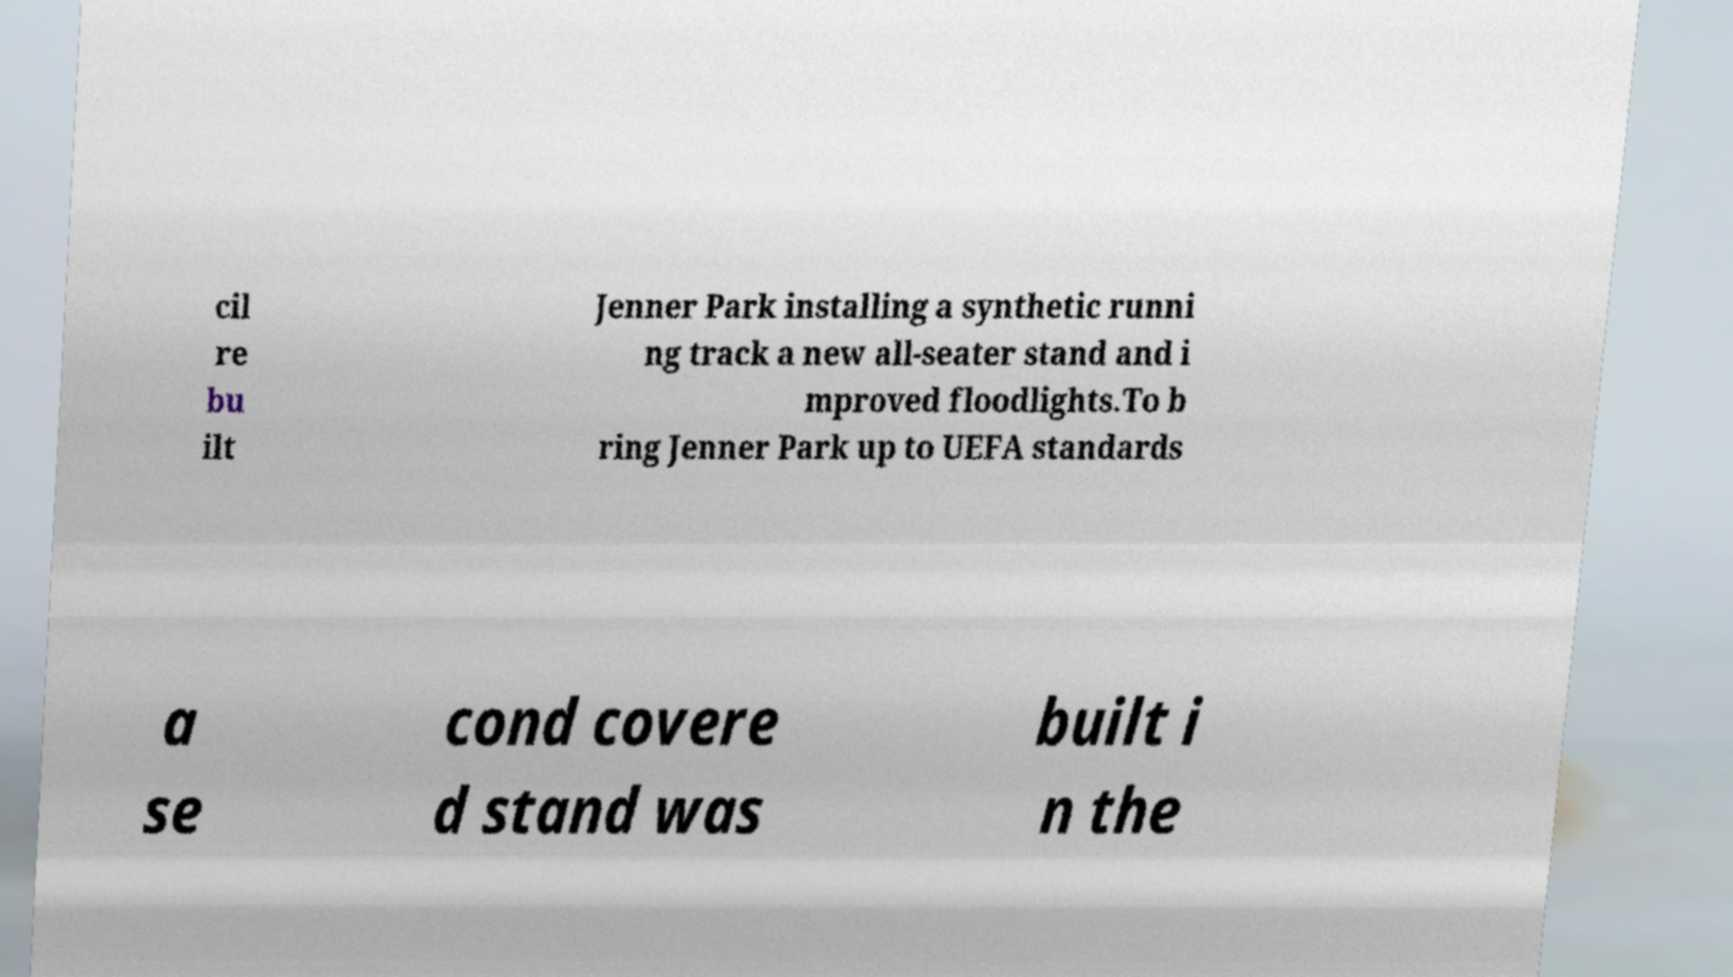There's text embedded in this image that I need extracted. Can you transcribe it verbatim? cil re bu ilt Jenner Park installing a synthetic runni ng track a new all-seater stand and i mproved floodlights.To b ring Jenner Park up to UEFA standards a se cond covere d stand was built i n the 